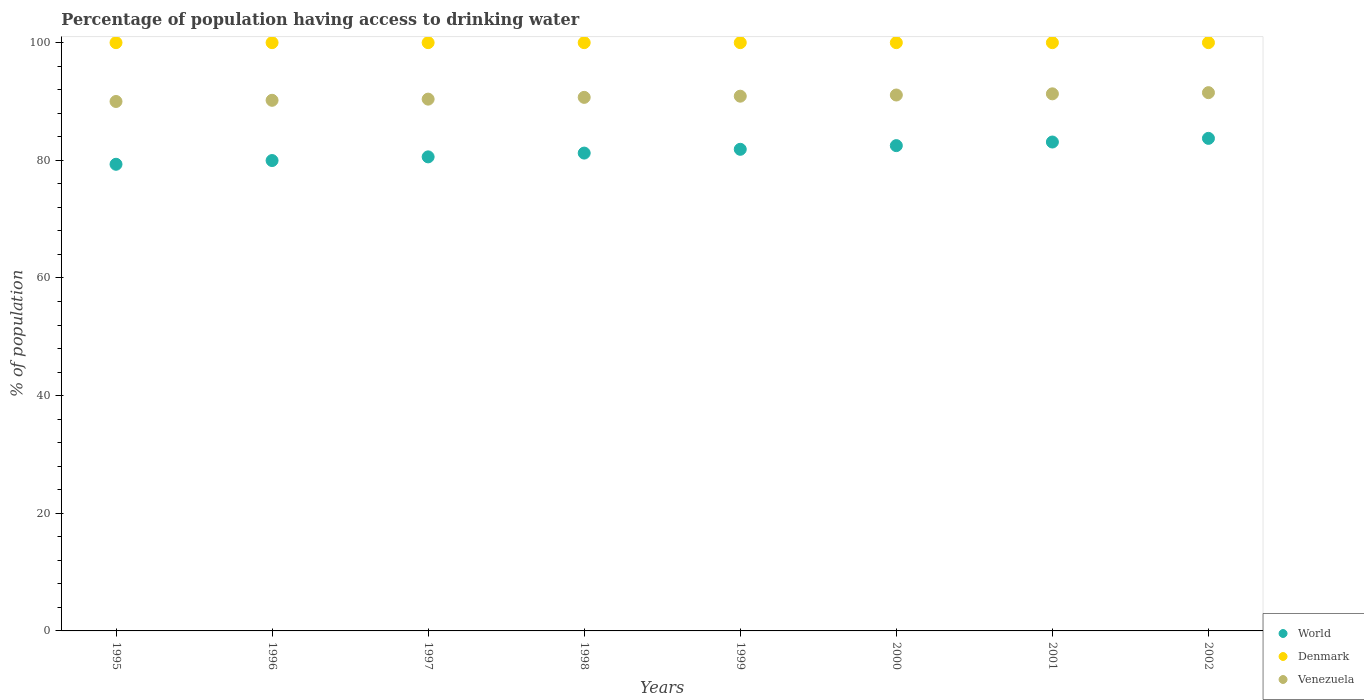What is the percentage of population having access to drinking water in World in 1999?
Your answer should be very brief. 81.87. Across all years, what is the maximum percentage of population having access to drinking water in Venezuela?
Provide a short and direct response. 91.5. Across all years, what is the minimum percentage of population having access to drinking water in World?
Your response must be concise. 79.33. In which year was the percentage of population having access to drinking water in World minimum?
Make the answer very short. 1995. What is the total percentage of population having access to drinking water in Denmark in the graph?
Your answer should be compact. 800. What is the difference between the percentage of population having access to drinking water in World in 2002 and the percentage of population having access to drinking water in Venezuela in 1999?
Ensure brevity in your answer.  -7.17. What is the average percentage of population having access to drinking water in Venezuela per year?
Your answer should be compact. 90.76. In the year 2000, what is the difference between the percentage of population having access to drinking water in Denmark and percentage of population having access to drinking water in World?
Offer a very short reply. 17.5. In how many years, is the percentage of population having access to drinking water in World greater than 68 %?
Your answer should be very brief. 8. What is the ratio of the percentage of population having access to drinking water in Venezuela in 1996 to that in 1999?
Your answer should be very brief. 0.99. Is the difference between the percentage of population having access to drinking water in Denmark in 1995 and 2001 greater than the difference between the percentage of population having access to drinking water in World in 1995 and 2001?
Your answer should be compact. Yes. What is the difference between the highest and the second highest percentage of population having access to drinking water in Venezuela?
Your response must be concise. 0.2. What is the difference between the highest and the lowest percentage of population having access to drinking water in World?
Keep it short and to the point. 4.4. In how many years, is the percentage of population having access to drinking water in World greater than the average percentage of population having access to drinking water in World taken over all years?
Offer a very short reply. 4. Does the percentage of population having access to drinking water in Venezuela monotonically increase over the years?
Your answer should be compact. Yes. Does the graph contain any zero values?
Give a very brief answer. No. Does the graph contain grids?
Provide a short and direct response. No. How many legend labels are there?
Your answer should be very brief. 3. How are the legend labels stacked?
Give a very brief answer. Vertical. What is the title of the graph?
Ensure brevity in your answer.  Percentage of population having access to drinking water. What is the label or title of the X-axis?
Provide a short and direct response. Years. What is the label or title of the Y-axis?
Give a very brief answer. % of population. What is the % of population in World in 1995?
Your answer should be very brief. 79.33. What is the % of population in World in 1996?
Your response must be concise. 79.96. What is the % of population of Denmark in 1996?
Ensure brevity in your answer.  100. What is the % of population in Venezuela in 1996?
Keep it short and to the point. 90.2. What is the % of population of World in 1997?
Keep it short and to the point. 80.58. What is the % of population in Denmark in 1997?
Provide a short and direct response. 100. What is the % of population in Venezuela in 1997?
Offer a very short reply. 90.4. What is the % of population in World in 1998?
Offer a terse response. 81.23. What is the % of population of Venezuela in 1998?
Your response must be concise. 90.7. What is the % of population of World in 1999?
Provide a succinct answer. 81.87. What is the % of population of Venezuela in 1999?
Offer a very short reply. 90.9. What is the % of population of World in 2000?
Make the answer very short. 82.5. What is the % of population of Denmark in 2000?
Give a very brief answer. 100. What is the % of population of Venezuela in 2000?
Ensure brevity in your answer.  91.1. What is the % of population in World in 2001?
Your answer should be compact. 83.11. What is the % of population in Denmark in 2001?
Offer a terse response. 100. What is the % of population of Venezuela in 2001?
Your answer should be very brief. 91.3. What is the % of population of World in 2002?
Your answer should be compact. 83.73. What is the % of population of Denmark in 2002?
Offer a terse response. 100. What is the % of population of Venezuela in 2002?
Ensure brevity in your answer.  91.5. Across all years, what is the maximum % of population of World?
Provide a succinct answer. 83.73. Across all years, what is the maximum % of population in Denmark?
Your answer should be very brief. 100. Across all years, what is the maximum % of population of Venezuela?
Your response must be concise. 91.5. Across all years, what is the minimum % of population of World?
Offer a very short reply. 79.33. What is the total % of population of World in the graph?
Give a very brief answer. 652.3. What is the total % of population of Denmark in the graph?
Make the answer very short. 800. What is the total % of population in Venezuela in the graph?
Provide a succinct answer. 726.1. What is the difference between the % of population of World in 1995 and that in 1996?
Make the answer very short. -0.63. What is the difference between the % of population in World in 1995 and that in 1997?
Ensure brevity in your answer.  -1.26. What is the difference between the % of population of World in 1995 and that in 1998?
Ensure brevity in your answer.  -1.9. What is the difference between the % of population in Venezuela in 1995 and that in 1998?
Ensure brevity in your answer.  -0.7. What is the difference between the % of population in World in 1995 and that in 1999?
Give a very brief answer. -2.55. What is the difference between the % of population of World in 1995 and that in 2000?
Offer a very short reply. -3.17. What is the difference between the % of population in World in 1995 and that in 2001?
Your response must be concise. -3.78. What is the difference between the % of population in World in 1995 and that in 2002?
Make the answer very short. -4.4. What is the difference between the % of population in World in 1996 and that in 1997?
Give a very brief answer. -0.63. What is the difference between the % of population in Denmark in 1996 and that in 1997?
Your response must be concise. 0. What is the difference between the % of population of Venezuela in 1996 and that in 1997?
Offer a terse response. -0.2. What is the difference between the % of population of World in 1996 and that in 1998?
Give a very brief answer. -1.27. What is the difference between the % of population in Denmark in 1996 and that in 1998?
Provide a succinct answer. 0. What is the difference between the % of population in Venezuela in 1996 and that in 1998?
Offer a terse response. -0.5. What is the difference between the % of population in World in 1996 and that in 1999?
Your answer should be compact. -1.91. What is the difference between the % of population in World in 1996 and that in 2000?
Offer a very short reply. -2.54. What is the difference between the % of population of Venezuela in 1996 and that in 2000?
Your response must be concise. -0.9. What is the difference between the % of population of World in 1996 and that in 2001?
Your answer should be very brief. -3.15. What is the difference between the % of population in Venezuela in 1996 and that in 2001?
Provide a succinct answer. -1.1. What is the difference between the % of population in World in 1996 and that in 2002?
Your answer should be very brief. -3.77. What is the difference between the % of population of World in 1997 and that in 1998?
Ensure brevity in your answer.  -0.64. What is the difference between the % of population in World in 1997 and that in 1999?
Provide a succinct answer. -1.29. What is the difference between the % of population of World in 1997 and that in 2000?
Give a very brief answer. -1.91. What is the difference between the % of population of World in 1997 and that in 2001?
Provide a succinct answer. -2.52. What is the difference between the % of population in Denmark in 1997 and that in 2001?
Your answer should be very brief. 0. What is the difference between the % of population in World in 1997 and that in 2002?
Your response must be concise. -3.15. What is the difference between the % of population in Denmark in 1997 and that in 2002?
Your answer should be very brief. 0. What is the difference between the % of population in Venezuela in 1997 and that in 2002?
Offer a terse response. -1.1. What is the difference between the % of population in World in 1998 and that in 1999?
Offer a very short reply. -0.64. What is the difference between the % of population in Venezuela in 1998 and that in 1999?
Provide a succinct answer. -0.2. What is the difference between the % of population of World in 1998 and that in 2000?
Give a very brief answer. -1.27. What is the difference between the % of population in Denmark in 1998 and that in 2000?
Give a very brief answer. 0. What is the difference between the % of population of Venezuela in 1998 and that in 2000?
Offer a very short reply. -0.4. What is the difference between the % of population in World in 1998 and that in 2001?
Your response must be concise. -1.88. What is the difference between the % of population of Venezuela in 1998 and that in 2001?
Provide a short and direct response. -0.6. What is the difference between the % of population of World in 1998 and that in 2002?
Provide a succinct answer. -2.5. What is the difference between the % of population of World in 1999 and that in 2000?
Your response must be concise. -0.63. What is the difference between the % of population of Venezuela in 1999 and that in 2000?
Provide a succinct answer. -0.2. What is the difference between the % of population in World in 1999 and that in 2001?
Provide a short and direct response. -1.24. What is the difference between the % of population in Venezuela in 1999 and that in 2001?
Give a very brief answer. -0.4. What is the difference between the % of population in World in 1999 and that in 2002?
Offer a terse response. -1.86. What is the difference between the % of population of Denmark in 1999 and that in 2002?
Keep it short and to the point. 0. What is the difference between the % of population of Venezuela in 1999 and that in 2002?
Give a very brief answer. -0.6. What is the difference between the % of population of World in 2000 and that in 2001?
Ensure brevity in your answer.  -0.61. What is the difference between the % of population of Denmark in 2000 and that in 2001?
Offer a very short reply. 0. What is the difference between the % of population of World in 2000 and that in 2002?
Make the answer very short. -1.23. What is the difference between the % of population in Venezuela in 2000 and that in 2002?
Ensure brevity in your answer.  -0.4. What is the difference between the % of population of World in 2001 and that in 2002?
Your response must be concise. -0.62. What is the difference between the % of population in Venezuela in 2001 and that in 2002?
Provide a short and direct response. -0.2. What is the difference between the % of population in World in 1995 and the % of population in Denmark in 1996?
Your answer should be very brief. -20.67. What is the difference between the % of population in World in 1995 and the % of population in Venezuela in 1996?
Your answer should be compact. -10.87. What is the difference between the % of population of Denmark in 1995 and the % of population of Venezuela in 1996?
Provide a succinct answer. 9.8. What is the difference between the % of population of World in 1995 and the % of population of Denmark in 1997?
Keep it short and to the point. -20.67. What is the difference between the % of population of World in 1995 and the % of population of Venezuela in 1997?
Provide a succinct answer. -11.07. What is the difference between the % of population of World in 1995 and the % of population of Denmark in 1998?
Provide a short and direct response. -20.67. What is the difference between the % of population in World in 1995 and the % of population in Venezuela in 1998?
Ensure brevity in your answer.  -11.37. What is the difference between the % of population in World in 1995 and the % of population in Denmark in 1999?
Offer a terse response. -20.67. What is the difference between the % of population of World in 1995 and the % of population of Venezuela in 1999?
Ensure brevity in your answer.  -11.57. What is the difference between the % of population of World in 1995 and the % of population of Denmark in 2000?
Keep it short and to the point. -20.67. What is the difference between the % of population in World in 1995 and the % of population in Venezuela in 2000?
Offer a very short reply. -11.77. What is the difference between the % of population of Denmark in 1995 and the % of population of Venezuela in 2000?
Your response must be concise. 8.9. What is the difference between the % of population in World in 1995 and the % of population in Denmark in 2001?
Your response must be concise. -20.67. What is the difference between the % of population in World in 1995 and the % of population in Venezuela in 2001?
Offer a terse response. -11.97. What is the difference between the % of population of World in 1995 and the % of population of Denmark in 2002?
Ensure brevity in your answer.  -20.67. What is the difference between the % of population of World in 1995 and the % of population of Venezuela in 2002?
Keep it short and to the point. -12.17. What is the difference between the % of population in World in 1996 and the % of population in Denmark in 1997?
Your answer should be compact. -20.04. What is the difference between the % of population of World in 1996 and the % of population of Venezuela in 1997?
Your response must be concise. -10.44. What is the difference between the % of population of World in 1996 and the % of population of Denmark in 1998?
Offer a terse response. -20.04. What is the difference between the % of population in World in 1996 and the % of population in Venezuela in 1998?
Your response must be concise. -10.74. What is the difference between the % of population of World in 1996 and the % of population of Denmark in 1999?
Give a very brief answer. -20.04. What is the difference between the % of population in World in 1996 and the % of population in Venezuela in 1999?
Your answer should be compact. -10.94. What is the difference between the % of population of Denmark in 1996 and the % of population of Venezuela in 1999?
Keep it short and to the point. 9.1. What is the difference between the % of population in World in 1996 and the % of population in Denmark in 2000?
Provide a succinct answer. -20.04. What is the difference between the % of population of World in 1996 and the % of population of Venezuela in 2000?
Ensure brevity in your answer.  -11.14. What is the difference between the % of population in World in 1996 and the % of population in Denmark in 2001?
Provide a short and direct response. -20.04. What is the difference between the % of population in World in 1996 and the % of population in Venezuela in 2001?
Provide a short and direct response. -11.34. What is the difference between the % of population of Denmark in 1996 and the % of population of Venezuela in 2001?
Provide a short and direct response. 8.7. What is the difference between the % of population in World in 1996 and the % of population in Denmark in 2002?
Your response must be concise. -20.04. What is the difference between the % of population of World in 1996 and the % of population of Venezuela in 2002?
Ensure brevity in your answer.  -11.54. What is the difference between the % of population in World in 1997 and the % of population in Denmark in 1998?
Your answer should be compact. -19.42. What is the difference between the % of population in World in 1997 and the % of population in Venezuela in 1998?
Provide a short and direct response. -10.12. What is the difference between the % of population in Denmark in 1997 and the % of population in Venezuela in 1998?
Make the answer very short. 9.3. What is the difference between the % of population of World in 1997 and the % of population of Denmark in 1999?
Keep it short and to the point. -19.42. What is the difference between the % of population of World in 1997 and the % of population of Venezuela in 1999?
Your answer should be compact. -10.32. What is the difference between the % of population of World in 1997 and the % of population of Denmark in 2000?
Offer a very short reply. -19.42. What is the difference between the % of population in World in 1997 and the % of population in Venezuela in 2000?
Ensure brevity in your answer.  -10.52. What is the difference between the % of population in Denmark in 1997 and the % of population in Venezuela in 2000?
Your response must be concise. 8.9. What is the difference between the % of population of World in 1997 and the % of population of Denmark in 2001?
Provide a succinct answer. -19.42. What is the difference between the % of population in World in 1997 and the % of population in Venezuela in 2001?
Offer a terse response. -10.72. What is the difference between the % of population in Denmark in 1997 and the % of population in Venezuela in 2001?
Keep it short and to the point. 8.7. What is the difference between the % of population of World in 1997 and the % of population of Denmark in 2002?
Ensure brevity in your answer.  -19.42. What is the difference between the % of population of World in 1997 and the % of population of Venezuela in 2002?
Keep it short and to the point. -10.92. What is the difference between the % of population in World in 1998 and the % of population in Denmark in 1999?
Provide a short and direct response. -18.77. What is the difference between the % of population in World in 1998 and the % of population in Venezuela in 1999?
Your response must be concise. -9.67. What is the difference between the % of population in World in 1998 and the % of population in Denmark in 2000?
Your answer should be compact. -18.77. What is the difference between the % of population in World in 1998 and the % of population in Venezuela in 2000?
Give a very brief answer. -9.87. What is the difference between the % of population in World in 1998 and the % of population in Denmark in 2001?
Offer a very short reply. -18.77. What is the difference between the % of population in World in 1998 and the % of population in Venezuela in 2001?
Offer a terse response. -10.07. What is the difference between the % of population of Denmark in 1998 and the % of population of Venezuela in 2001?
Provide a succinct answer. 8.7. What is the difference between the % of population of World in 1998 and the % of population of Denmark in 2002?
Make the answer very short. -18.77. What is the difference between the % of population in World in 1998 and the % of population in Venezuela in 2002?
Your answer should be compact. -10.27. What is the difference between the % of population of World in 1999 and the % of population of Denmark in 2000?
Keep it short and to the point. -18.13. What is the difference between the % of population in World in 1999 and the % of population in Venezuela in 2000?
Make the answer very short. -9.23. What is the difference between the % of population of World in 1999 and the % of population of Denmark in 2001?
Your answer should be compact. -18.13. What is the difference between the % of population in World in 1999 and the % of population in Venezuela in 2001?
Your response must be concise. -9.43. What is the difference between the % of population of Denmark in 1999 and the % of population of Venezuela in 2001?
Your response must be concise. 8.7. What is the difference between the % of population of World in 1999 and the % of population of Denmark in 2002?
Your response must be concise. -18.13. What is the difference between the % of population of World in 1999 and the % of population of Venezuela in 2002?
Ensure brevity in your answer.  -9.63. What is the difference between the % of population of Denmark in 1999 and the % of population of Venezuela in 2002?
Offer a terse response. 8.5. What is the difference between the % of population in World in 2000 and the % of population in Denmark in 2001?
Your answer should be very brief. -17.5. What is the difference between the % of population of World in 2000 and the % of population of Venezuela in 2001?
Offer a very short reply. -8.8. What is the difference between the % of population of Denmark in 2000 and the % of population of Venezuela in 2001?
Your response must be concise. 8.7. What is the difference between the % of population in World in 2000 and the % of population in Denmark in 2002?
Provide a succinct answer. -17.5. What is the difference between the % of population in World in 2000 and the % of population in Venezuela in 2002?
Your answer should be very brief. -9. What is the difference between the % of population of Denmark in 2000 and the % of population of Venezuela in 2002?
Provide a short and direct response. 8.5. What is the difference between the % of population in World in 2001 and the % of population in Denmark in 2002?
Offer a very short reply. -16.89. What is the difference between the % of population in World in 2001 and the % of population in Venezuela in 2002?
Give a very brief answer. -8.39. What is the difference between the % of population in Denmark in 2001 and the % of population in Venezuela in 2002?
Offer a terse response. 8.5. What is the average % of population of World per year?
Ensure brevity in your answer.  81.54. What is the average % of population of Denmark per year?
Keep it short and to the point. 100. What is the average % of population of Venezuela per year?
Ensure brevity in your answer.  90.76. In the year 1995, what is the difference between the % of population in World and % of population in Denmark?
Make the answer very short. -20.67. In the year 1995, what is the difference between the % of population of World and % of population of Venezuela?
Provide a succinct answer. -10.67. In the year 1995, what is the difference between the % of population in Denmark and % of population in Venezuela?
Ensure brevity in your answer.  10. In the year 1996, what is the difference between the % of population of World and % of population of Denmark?
Your answer should be very brief. -20.04. In the year 1996, what is the difference between the % of population in World and % of population in Venezuela?
Give a very brief answer. -10.24. In the year 1997, what is the difference between the % of population of World and % of population of Denmark?
Give a very brief answer. -19.42. In the year 1997, what is the difference between the % of population of World and % of population of Venezuela?
Make the answer very short. -9.82. In the year 1997, what is the difference between the % of population of Denmark and % of population of Venezuela?
Offer a terse response. 9.6. In the year 1998, what is the difference between the % of population of World and % of population of Denmark?
Your answer should be very brief. -18.77. In the year 1998, what is the difference between the % of population in World and % of population in Venezuela?
Your response must be concise. -9.47. In the year 1998, what is the difference between the % of population of Denmark and % of population of Venezuela?
Keep it short and to the point. 9.3. In the year 1999, what is the difference between the % of population in World and % of population in Denmark?
Give a very brief answer. -18.13. In the year 1999, what is the difference between the % of population in World and % of population in Venezuela?
Provide a short and direct response. -9.03. In the year 2000, what is the difference between the % of population in World and % of population in Denmark?
Provide a short and direct response. -17.5. In the year 2000, what is the difference between the % of population of World and % of population of Venezuela?
Keep it short and to the point. -8.6. In the year 2001, what is the difference between the % of population in World and % of population in Denmark?
Offer a terse response. -16.89. In the year 2001, what is the difference between the % of population of World and % of population of Venezuela?
Offer a terse response. -8.19. In the year 2001, what is the difference between the % of population of Denmark and % of population of Venezuela?
Provide a short and direct response. 8.7. In the year 2002, what is the difference between the % of population in World and % of population in Denmark?
Ensure brevity in your answer.  -16.27. In the year 2002, what is the difference between the % of population in World and % of population in Venezuela?
Offer a terse response. -7.77. In the year 2002, what is the difference between the % of population in Denmark and % of population in Venezuela?
Ensure brevity in your answer.  8.5. What is the ratio of the % of population in World in 1995 to that in 1996?
Ensure brevity in your answer.  0.99. What is the ratio of the % of population of Denmark in 1995 to that in 1996?
Make the answer very short. 1. What is the ratio of the % of population of Venezuela in 1995 to that in 1996?
Make the answer very short. 1. What is the ratio of the % of population in World in 1995 to that in 1997?
Offer a terse response. 0.98. What is the ratio of the % of population in Venezuela in 1995 to that in 1997?
Provide a short and direct response. 1. What is the ratio of the % of population of World in 1995 to that in 1998?
Keep it short and to the point. 0.98. What is the ratio of the % of population of Denmark in 1995 to that in 1998?
Your response must be concise. 1. What is the ratio of the % of population of Venezuela in 1995 to that in 1998?
Ensure brevity in your answer.  0.99. What is the ratio of the % of population of World in 1995 to that in 1999?
Provide a succinct answer. 0.97. What is the ratio of the % of population in World in 1995 to that in 2000?
Your answer should be very brief. 0.96. What is the ratio of the % of population of Venezuela in 1995 to that in 2000?
Provide a short and direct response. 0.99. What is the ratio of the % of population of World in 1995 to that in 2001?
Make the answer very short. 0.95. What is the ratio of the % of population in Denmark in 1995 to that in 2001?
Your response must be concise. 1. What is the ratio of the % of population of Venezuela in 1995 to that in 2001?
Give a very brief answer. 0.99. What is the ratio of the % of population of World in 1995 to that in 2002?
Offer a very short reply. 0.95. What is the ratio of the % of population of Denmark in 1995 to that in 2002?
Your response must be concise. 1. What is the ratio of the % of population of Venezuela in 1995 to that in 2002?
Provide a short and direct response. 0.98. What is the ratio of the % of population of Venezuela in 1996 to that in 1997?
Keep it short and to the point. 1. What is the ratio of the % of population in World in 1996 to that in 1998?
Ensure brevity in your answer.  0.98. What is the ratio of the % of population of Denmark in 1996 to that in 1998?
Your answer should be very brief. 1. What is the ratio of the % of population in World in 1996 to that in 1999?
Offer a terse response. 0.98. What is the ratio of the % of population of World in 1996 to that in 2000?
Give a very brief answer. 0.97. What is the ratio of the % of population of Denmark in 1996 to that in 2000?
Offer a very short reply. 1. What is the ratio of the % of population of World in 1996 to that in 2001?
Your answer should be compact. 0.96. What is the ratio of the % of population in Venezuela in 1996 to that in 2001?
Keep it short and to the point. 0.99. What is the ratio of the % of population of World in 1996 to that in 2002?
Provide a short and direct response. 0.95. What is the ratio of the % of population in Denmark in 1996 to that in 2002?
Provide a short and direct response. 1. What is the ratio of the % of population in Venezuela in 1996 to that in 2002?
Ensure brevity in your answer.  0.99. What is the ratio of the % of population of World in 1997 to that in 1998?
Give a very brief answer. 0.99. What is the ratio of the % of population in Venezuela in 1997 to that in 1998?
Provide a succinct answer. 1. What is the ratio of the % of population of World in 1997 to that in 1999?
Give a very brief answer. 0.98. What is the ratio of the % of population in World in 1997 to that in 2000?
Ensure brevity in your answer.  0.98. What is the ratio of the % of population in Denmark in 1997 to that in 2000?
Offer a very short reply. 1. What is the ratio of the % of population of Venezuela in 1997 to that in 2000?
Give a very brief answer. 0.99. What is the ratio of the % of population of World in 1997 to that in 2001?
Provide a succinct answer. 0.97. What is the ratio of the % of population of World in 1997 to that in 2002?
Provide a short and direct response. 0.96. What is the ratio of the % of population of Venezuela in 1997 to that in 2002?
Give a very brief answer. 0.99. What is the ratio of the % of population in World in 1998 to that in 1999?
Ensure brevity in your answer.  0.99. What is the ratio of the % of population in Denmark in 1998 to that in 1999?
Offer a very short reply. 1. What is the ratio of the % of population in World in 1998 to that in 2000?
Give a very brief answer. 0.98. What is the ratio of the % of population of Denmark in 1998 to that in 2000?
Your response must be concise. 1. What is the ratio of the % of population of World in 1998 to that in 2001?
Give a very brief answer. 0.98. What is the ratio of the % of population in World in 1998 to that in 2002?
Keep it short and to the point. 0.97. What is the ratio of the % of population of World in 1999 to that in 2000?
Offer a very short reply. 0.99. What is the ratio of the % of population in Venezuela in 1999 to that in 2000?
Your answer should be compact. 1. What is the ratio of the % of population of World in 1999 to that in 2001?
Your answer should be compact. 0.99. What is the ratio of the % of population of Venezuela in 1999 to that in 2001?
Give a very brief answer. 1. What is the ratio of the % of population of World in 1999 to that in 2002?
Offer a terse response. 0.98. What is the ratio of the % of population in World in 2000 to that in 2001?
Provide a short and direct response. 0.99. What is the ratio of the % of population of World in 2000 to that in 2002?
Provide a short and direct response. 0.99. What is the ratio of the % of population in Denmark in 2000 to that in 2002?
Your answer should be very brief. 1. What is the ratio of the % of population in Venezuela in 2000 to that in 2002?
Provide a succinct answer. 1. What is the difference between the highest and the second highest % of population of World?
Give a very brief answer. 0.62. What is the difference between the highest and the second highest % of population in Denmark?
Provide a succinct answer. 0. What is the difference between the highest and the lowest % of population of World?
Your answer should be very brief. 4.4. What is the difference between the highest and the lowest % of population in Denmark?
Your answer should be compact. 0. What is the difference between the highest and the lowest % of population of Venezuela?
Ensure brevity in your answer.  1.5. 